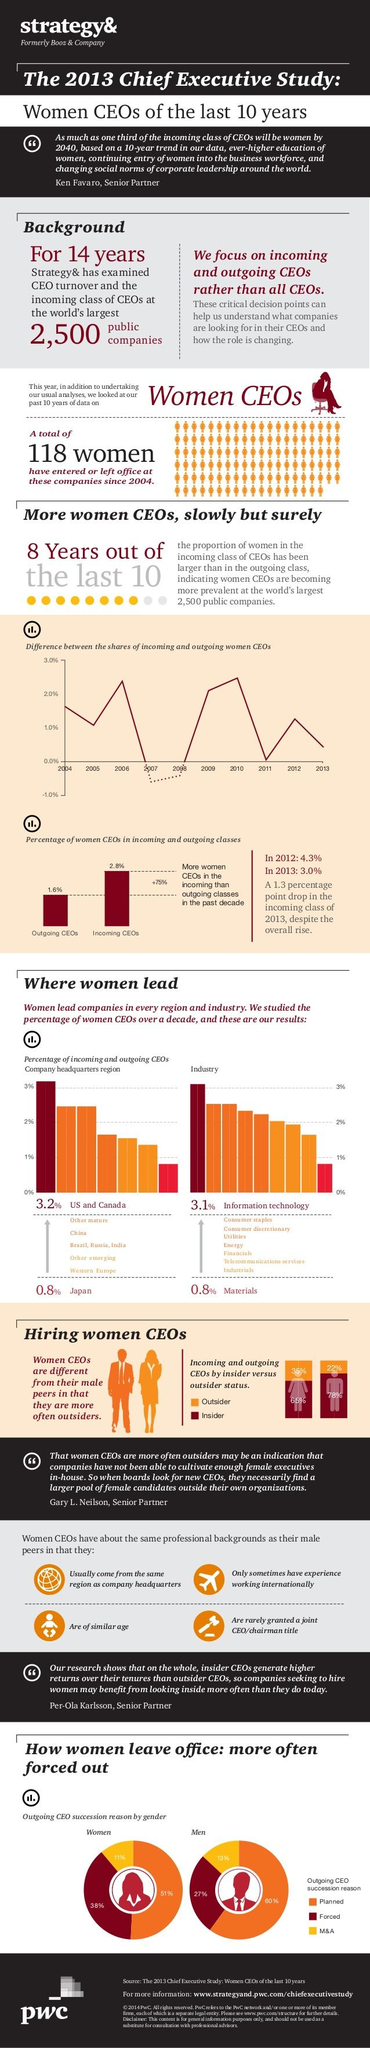Point out several critical features in this image. In the past five years, a total of 4.4% of incoming and outgoing CEOs have been women. 